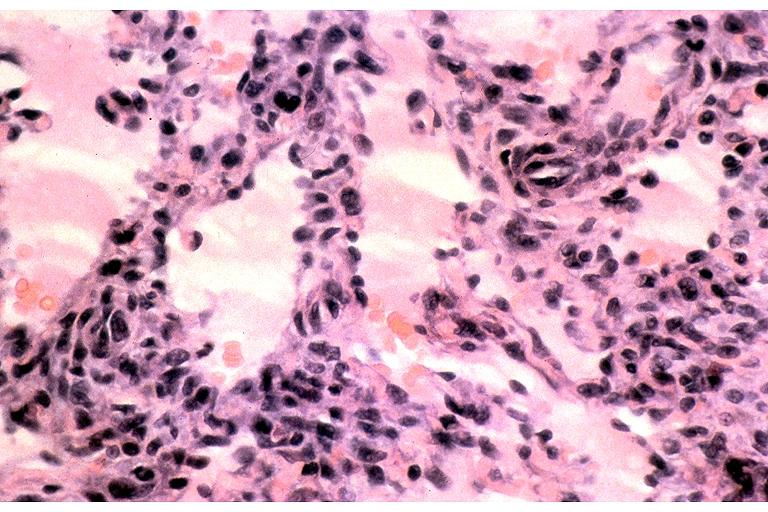s oral present?
Answer the question using a single word or phrase. Yes 